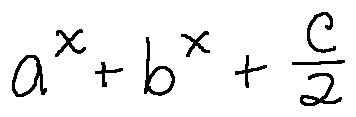<formula> <loc_0><loc_0><loc_500><loc_500>a ^ { x } + b ^ { x } + \frac { c } { 2 }</formula> 